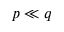Convert formula to latex. <formula><loc_0><loc_0><loc_500><loc_500>p \ll q</formula> 